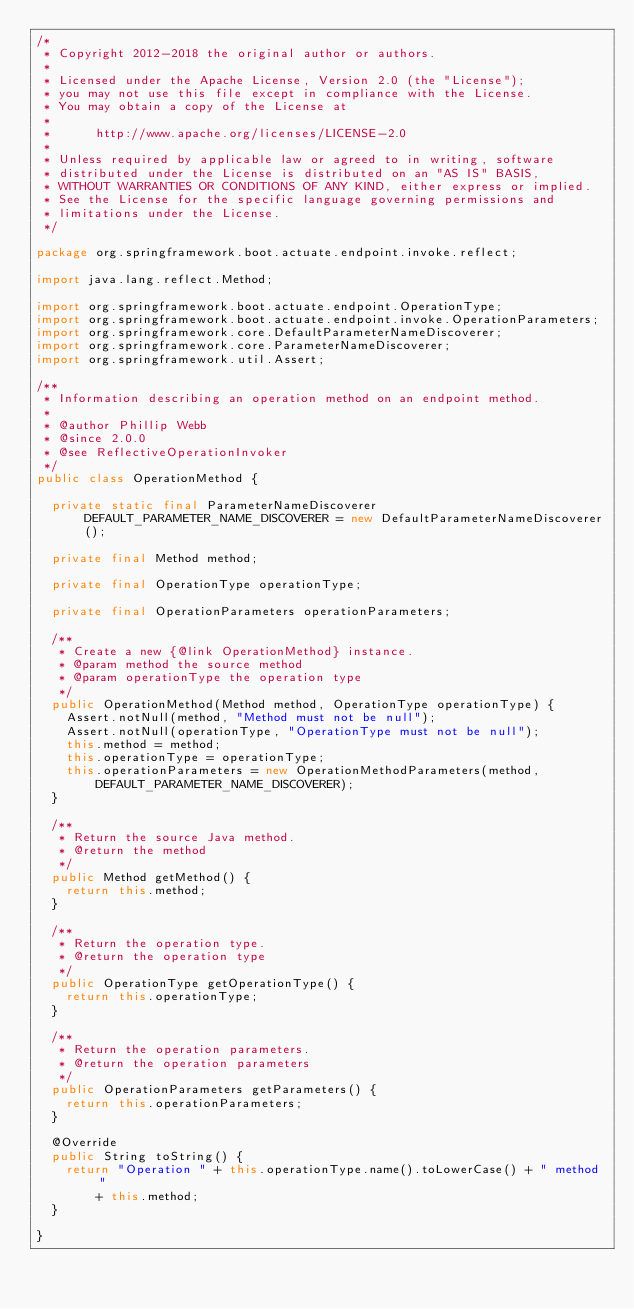Convert code to text. <code><loc_0><loc_0><loc_500><loc_500><_Java_>/*
 * Copyright 2012-2018 the original author or authors.
 *
 * Licensed under the Apache License, Version 2.0 (the "License");
 * you may not use this file except in compliance with the License.
 * You may obtain a copy of the License at
 *
 *      http://www.apache.org/licenses/LICENSE-2.0
 *
 * Unless required by applicable law or agreed to in writing, software
 * distributed under the License is distributed on an "AS IS" BASIS,
 * WITHOUT WARRANTIES OR CONDITIONS OF ANY KIND, either express or implied.
 * See the License for the specific language governing permissions and
 * limitations under the License.
 */

package org.springframework.boot.actuate.endpoint.invoke.reflect;

import java.lang.reflect.Method;

import org.springframework.boot.actuate.endpoint.OperationType;
import org.springframework.boot.actuate.endpoint.invoke.OperationParameters;
import org.springframework.core.DefaultParameterNameDiscoverer;
import org.springframework.core.ParameterNameDiscoverer;
import org.springframework.util.Assert;

/**
 * Information describing an operation method on an endpoint method.
 *
 * @author Phillip Webb
 * @since 2.0.0
 * @see ReflectiveOperationInvoker
 */
public class OperationMethod {

	private static final ParameterNameDiscoverer DEFAULT_PARAMETER_NAME_DISCOVERER = new DefaultParameterNameDiscoverer();

	private final Method method;

	private final OperationType operationType;

	private final OperationParameters operationParameters;

	/**
	 * Create a new {@link OperationMethod} instance.
	 * @param method the source method
	 * @param operationType the operation type
	 */
	public OperationMethod(Method method, OperationType operationType) {
		Assert.notNull(method, "Method must not be null");
		Assert.notNull(operationType, "OperationType must not be null");
		this.method = method;
		this.operationType = operationType;
		this.operationParameters = new OperationMethodParameters(method,
				DEFAULT_PARAMETER_NAME_DISCOVERER);
	}

	/**
	 * Return the source Java method.
	 * @return the method
	 */
	public Method getMethod() {
		return this.method;
	}

	/**
	 * Return the operation type.
	 * @return the operation type
	 */
	public OperationType getOperationType() {
		return this.operationType;
	}

	/**
	 * Return the operation parameters.
	 * @return the operation parameters
	 */
	public OperationParameters getParameters() {
		return this.operationParameters;
	}

	@Override
	public String toString() {
		return "Operation " + this.operationType.name().toLowerCase() + " method "
				+ this.method;
	}

}
</code> 